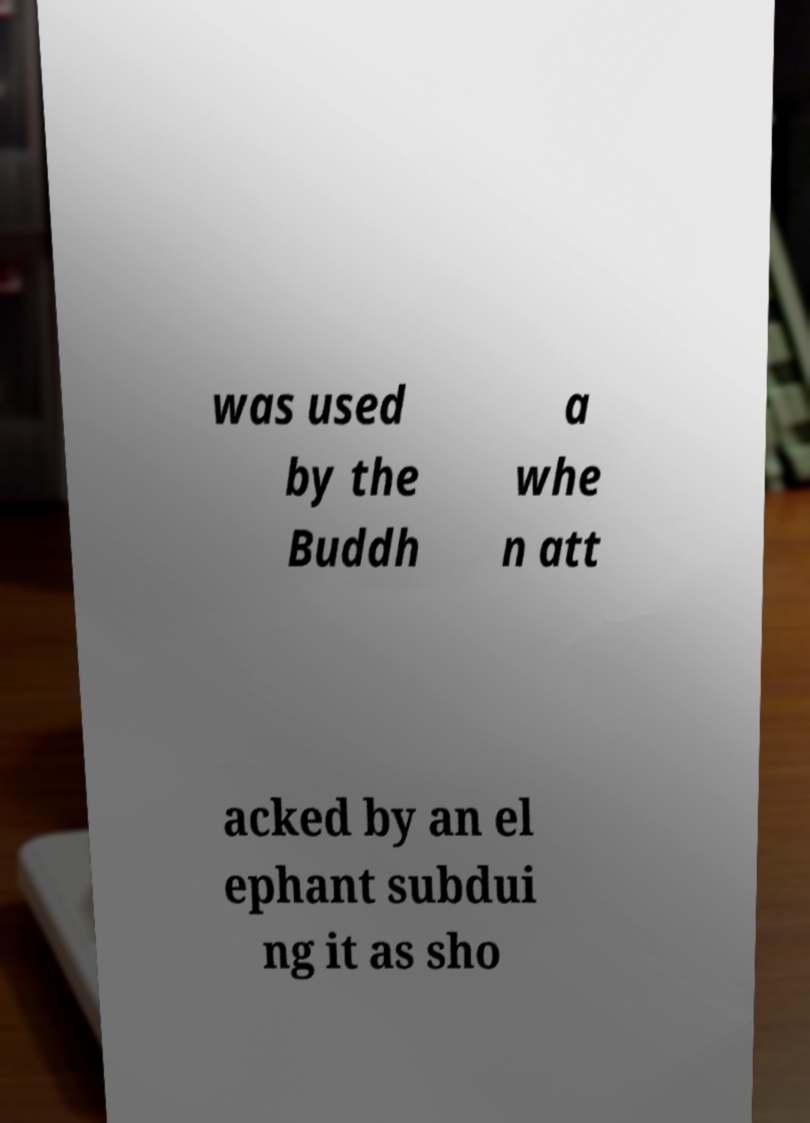Can you accurately transcribe the text from the provided image for me? was used by the Buddh a whe n att acked by an el ephant subdui ng it as sho 